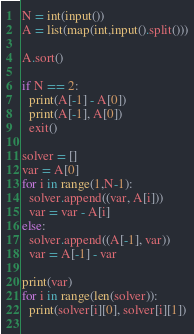<code> <loc_0><loc_0><loc_500><loc_500><_Python_>N = int(input())
A = list(map(int,input().split()))

A.sort()

if N == 2:
  print(A[-1] - A[0])
  print(A[-1], A[0])
  exit()

solver = []
var = A[0]
for i in range(1,N-1):
  solver.append((var, A[i]))
  var = var - A[i]
else:
  solver.append((A[-1], var))
  var = A[-1] - var

print(var)
for i in range(len(solver)):
  print(solver[i][0], solver[i][1])
 </code> 